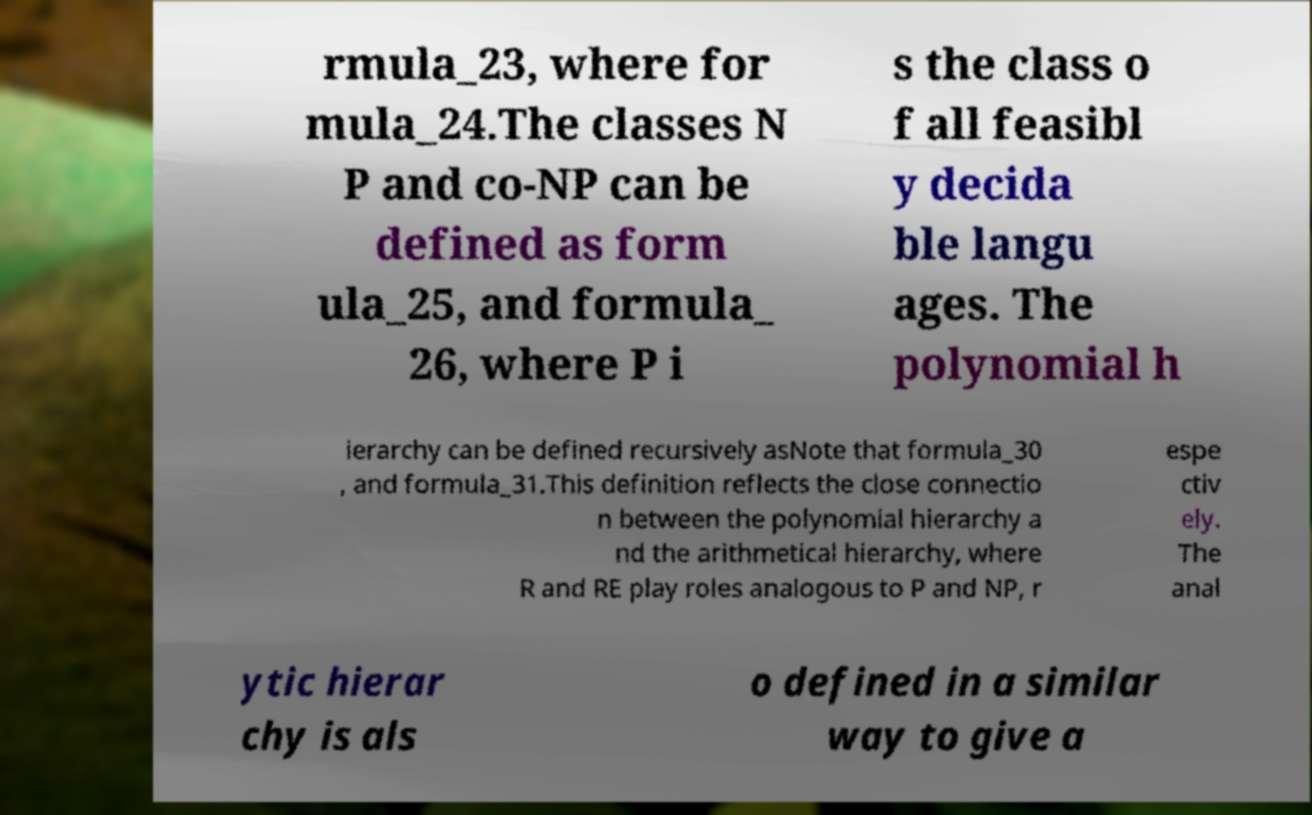Could you extract and type out the text from this image? rmula_23, where for mula_24.The classes N P and co-NP can be defined as form ula_25, and formula_ 26, where P i s the class o f all feasibl y decida ble langu ages. The polynomial h ierarchy can be defined recursively asNote that formula_30 , and formula_31.This definition reflects the close connectio n between the polynomial hierarchy a nd the arithmetical hierarchy, where R and RE play roles analogous to P and NP, r espe ctiv ely. The anal ytic hierar chy is als o defined in a similar way to give a 